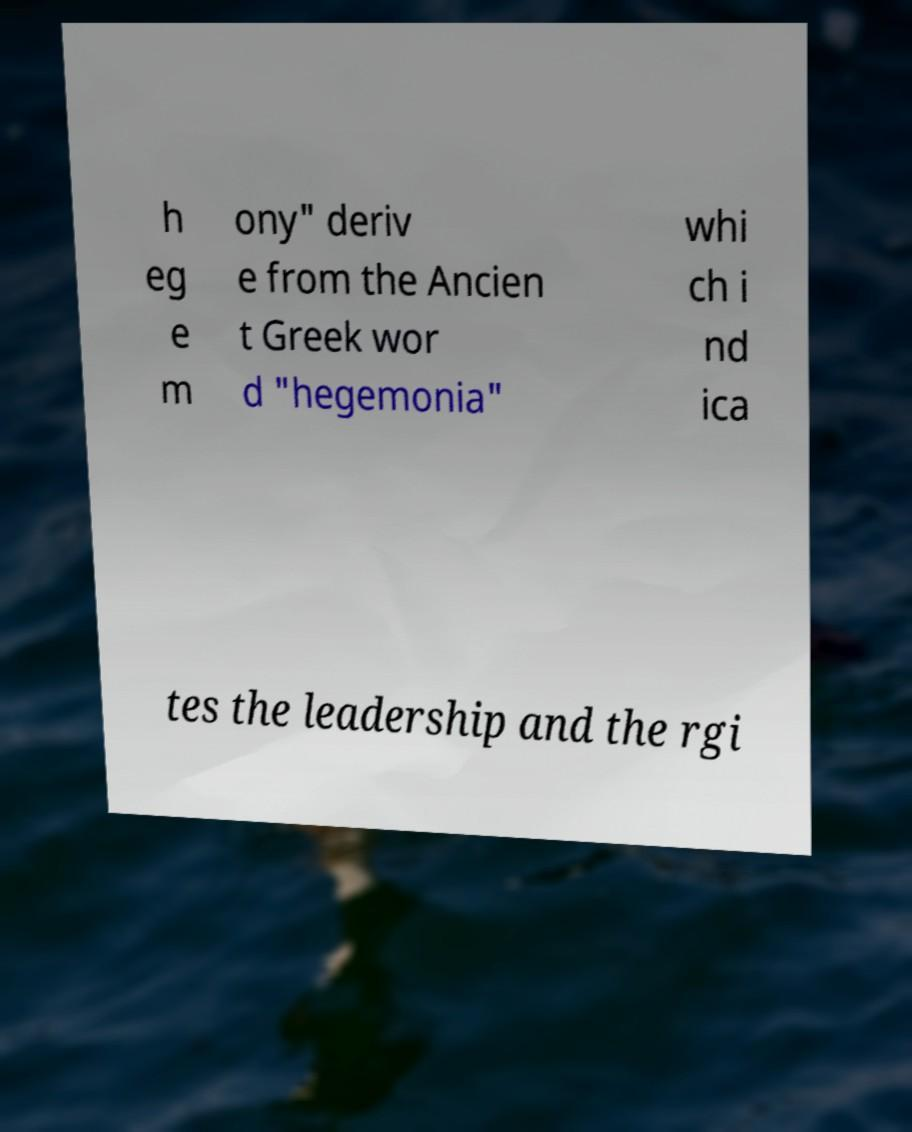For documentation purposes, I need the text within this image transcribed. Could you provide that? h eg e m ony" deriv e from the Ancien t Greek wor d "hegemonia" whi ch i nd ica tes the leadership and the rgi 